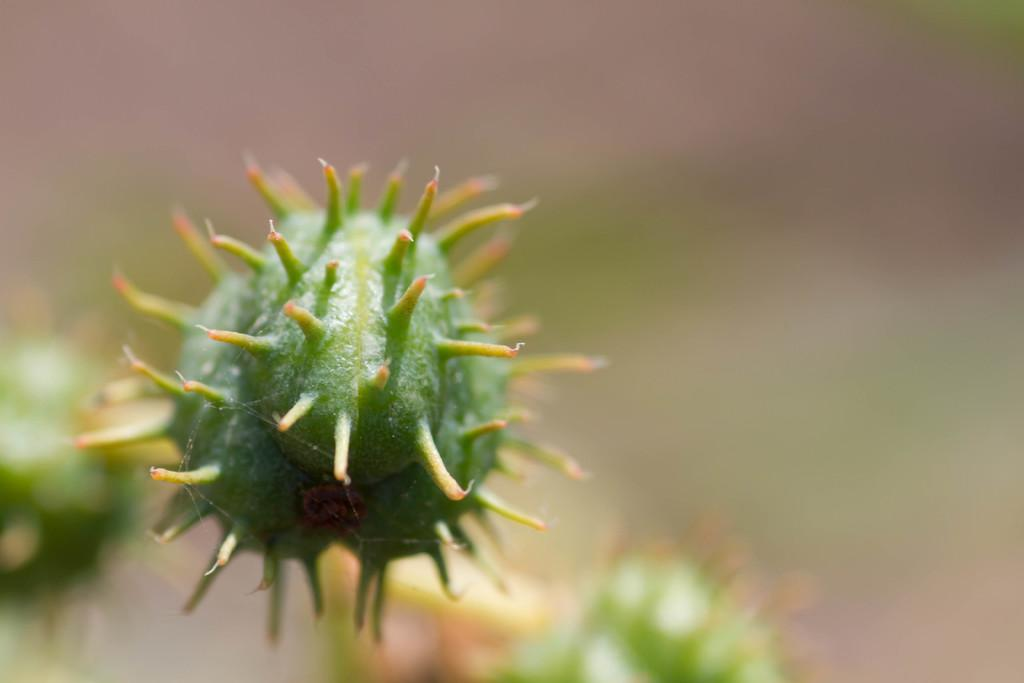What is the main subject of the image? There is a flower in the center of the image. Can you describe the flower in more detail? Unfortunately, the facts provided do not give any additional details about the flower. Is there anything else in the image besides the flower? The facts provided do not mention any other objects or subjects in the image. What type of apparel is being worn by the flower in the image? There is no apparel present in the image, as it features a flower and nothing else. 